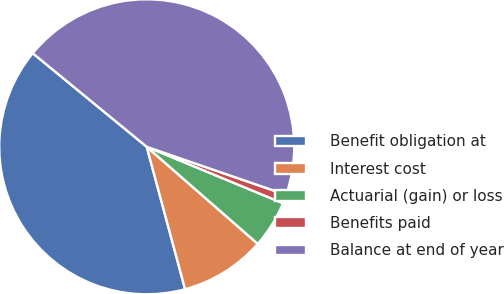<chart> <loc_0><loc_0><loc_500><loc_500><pie_chart><fcel>Benefit obligation at<fcel>Interest cost<fcel>Actuarial (gain) or loss<fcel>Benefits paid<fcel>Balance at end of year<nl><fcel>40.13%<fcel>9.38%<fcel>5.18%<fcel>0.97%<fcel>44.34%<nl></chart> 